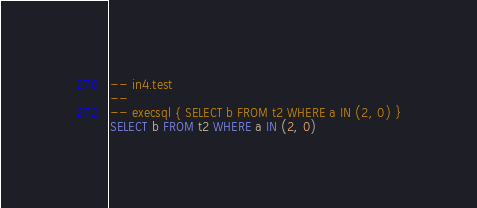<code> <loc_0><loc_0><loc_500><loc_500><_SQL_>-- in4.test
-- 
-- execsql { SELECT b FROM t2 WHERE a IN (2, 0) }
SELECT b FROM t2 WHERE a IN (2, 0)</code> 